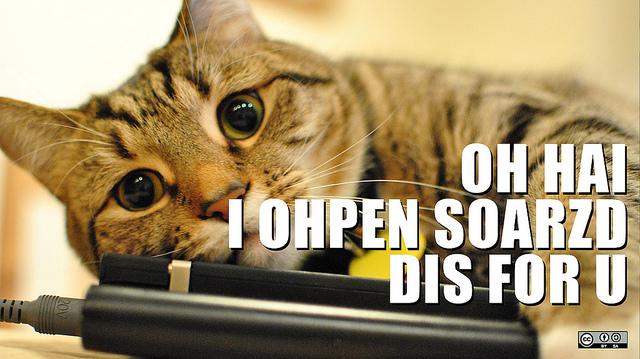What is the cats coats color pattern referred to as?
Answer briefly. Tabby. What are the grammatical errors?
Be succinct. All of it. Is this a cat or a tiger?
Be succinct. Cat. 